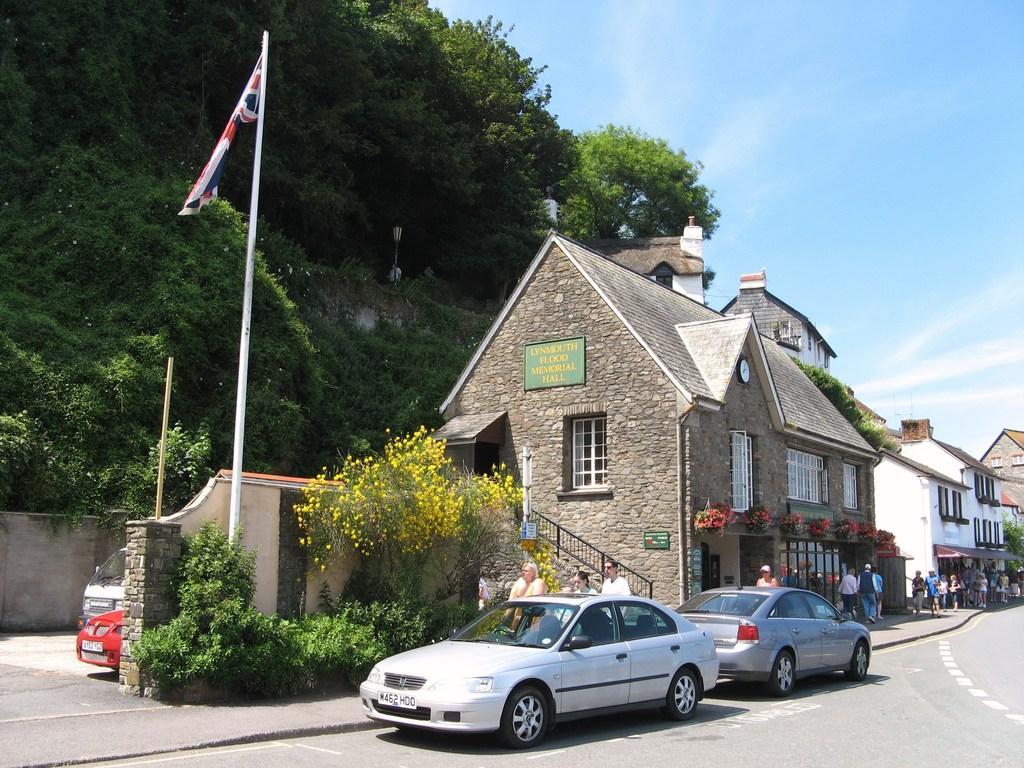In one or two sentences, can you explain what this image depicts? In this image I can see few vehicles and I can also see few persons standing. Background I can see few trees in green color, a flag in red, white and blue color, buildings in white and brown color and the sky is in blue color. 